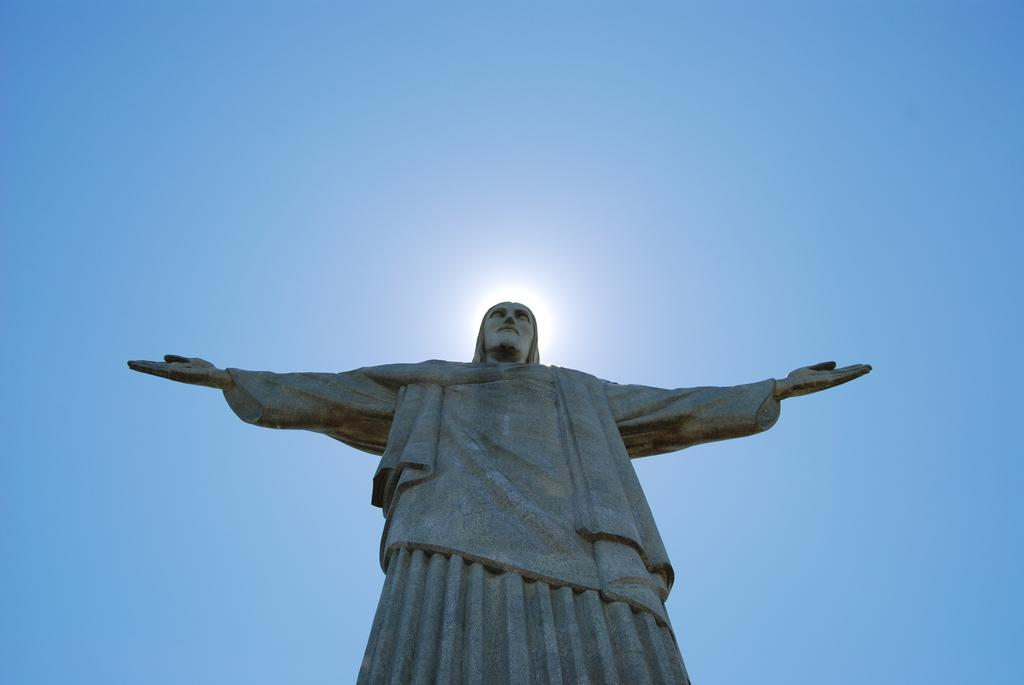What is the main subject in the picture? There is a statue in the picture. What can be seen in the sky in the image? There are clouds visible in the sky. What type of juice is being poured from the drum in the image? There is no drum or juice present in the image; it only features a statue and clouds in the sky. 